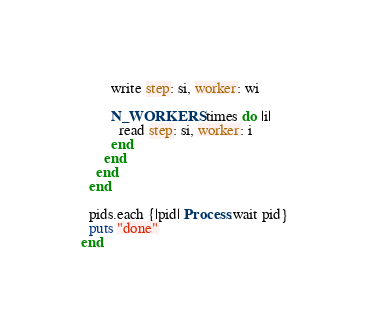<code> <loc_0><loc_0><loc_500><loc_500><_Ruby_>        write step: si, worker: wi

        N_WORKERS.times do |i|
          read step: si, worker: i
        end
      end
    end
  end
  
  pids.each {|pid| Process.wait pid}
  puts "done"
end
</code> 